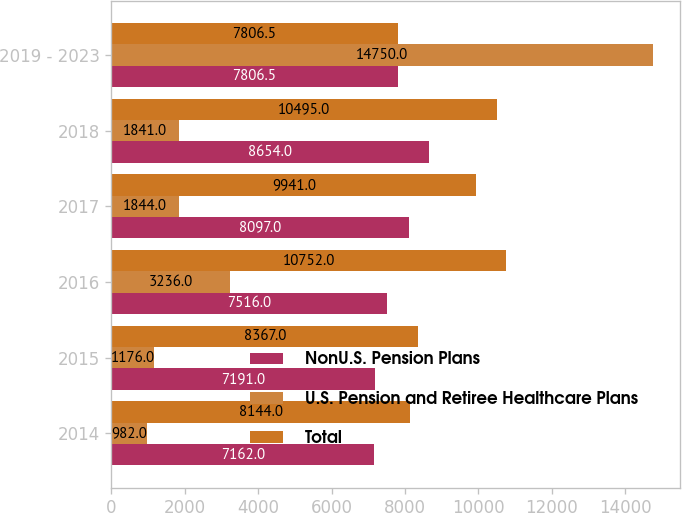Convert chart to OTSL. <chart><loc_0><loc_0><loc_500><loc_500><stacked_bar_chart><ecel><fcel>2014<fcel>2015<fcel>2016<fcel>2017<fcel>2018<fcel>2019 - 2023<nl><fcel>NonU.S. Pension Plans<fcel>7162<fcel>7191<fcel>7516<fcel>8097<fcel>8654<fcel>7806.5<nl><fcel>U.S. Pension and Retiree Healthcare Plans<fcel>982<fcel>1176<fcel>3236<fcel>1844<fcel>1841<fcel>14750<nl><fcel>Total<fcel>8144<fcel>8367<fcel>10752<fcel>9941<fcel>10495<fcel>7806.5<nl></chart> 